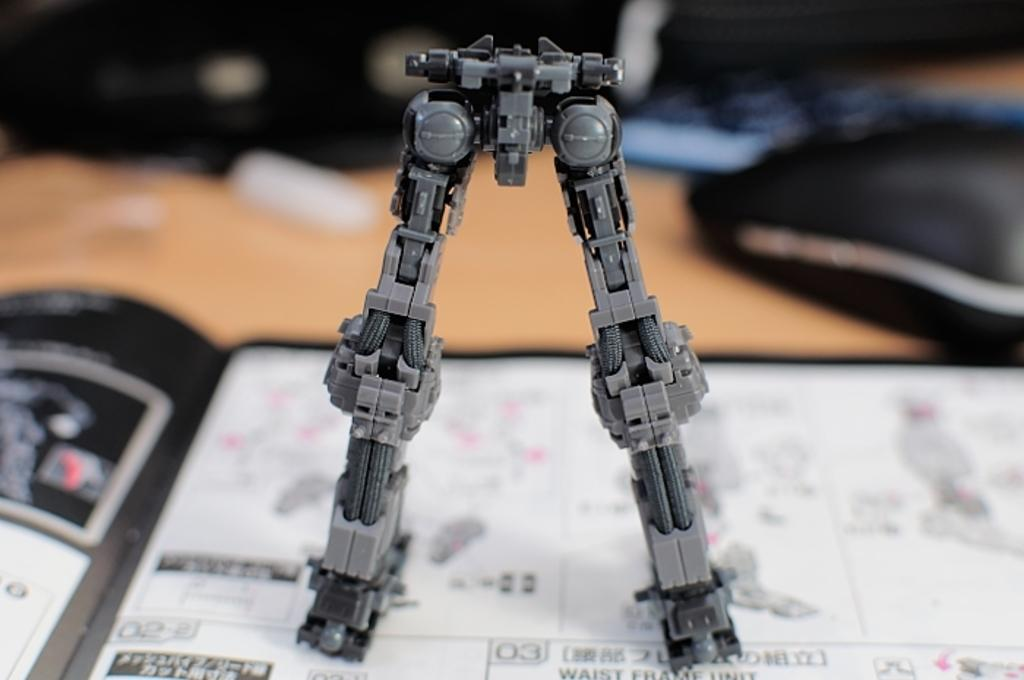What is the main object in the foreground of the image? There is a toy-like object in the foreground of the image. What is the toy-like object placed on? The toy-like object appears to be on a brochure. Can you describe the background of the image? The background of the image is blurry. How many circles can be seen on the hill in the image? There is no hill or circles present in the image. 